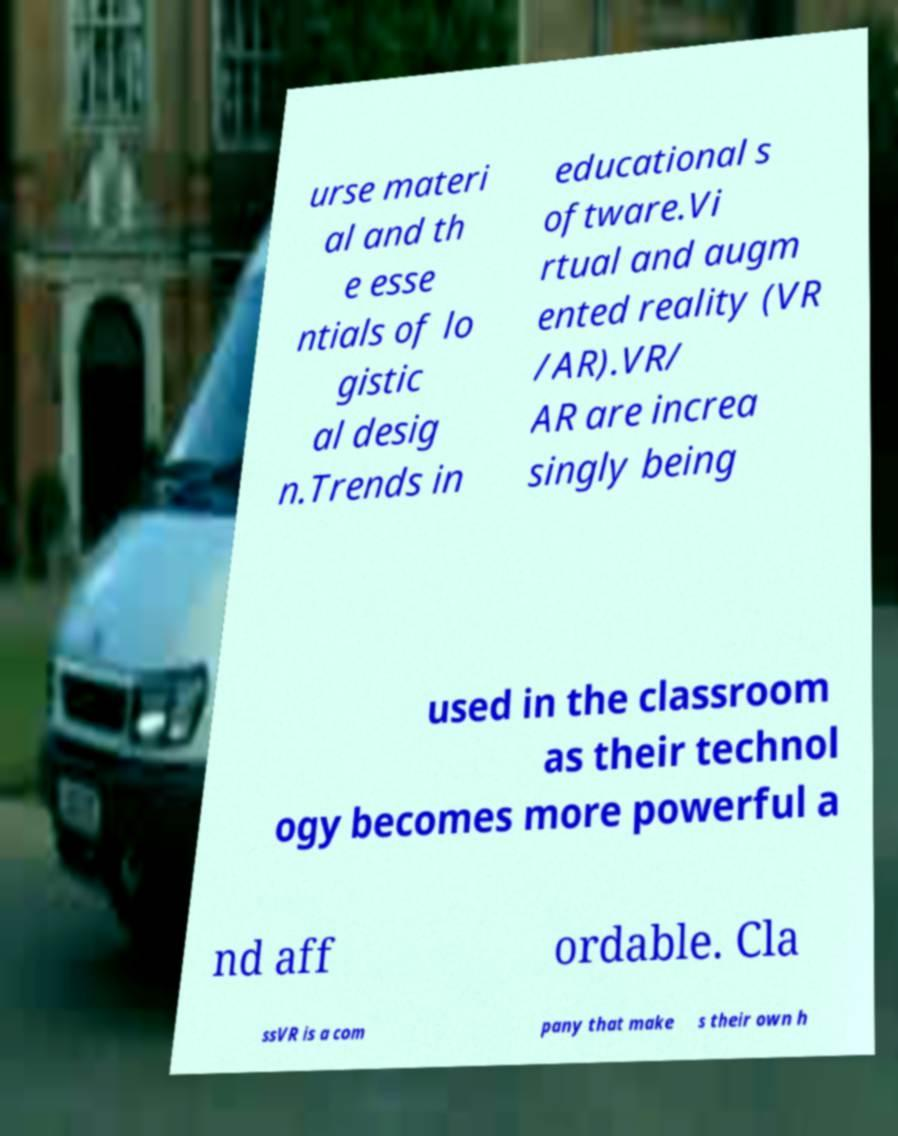Could you extract and type out the text from this image? urse materi al and th e esse ntials of lo gistic al desig n.Trends in educational s oftware.Vi rtual and augm ented reality (VR /AR).VR/ AR are increa singly being used in the classroom as their technol ogy becomes more powerful a nd aff ordable. Cla ssVR is a com pany that make s their own h 